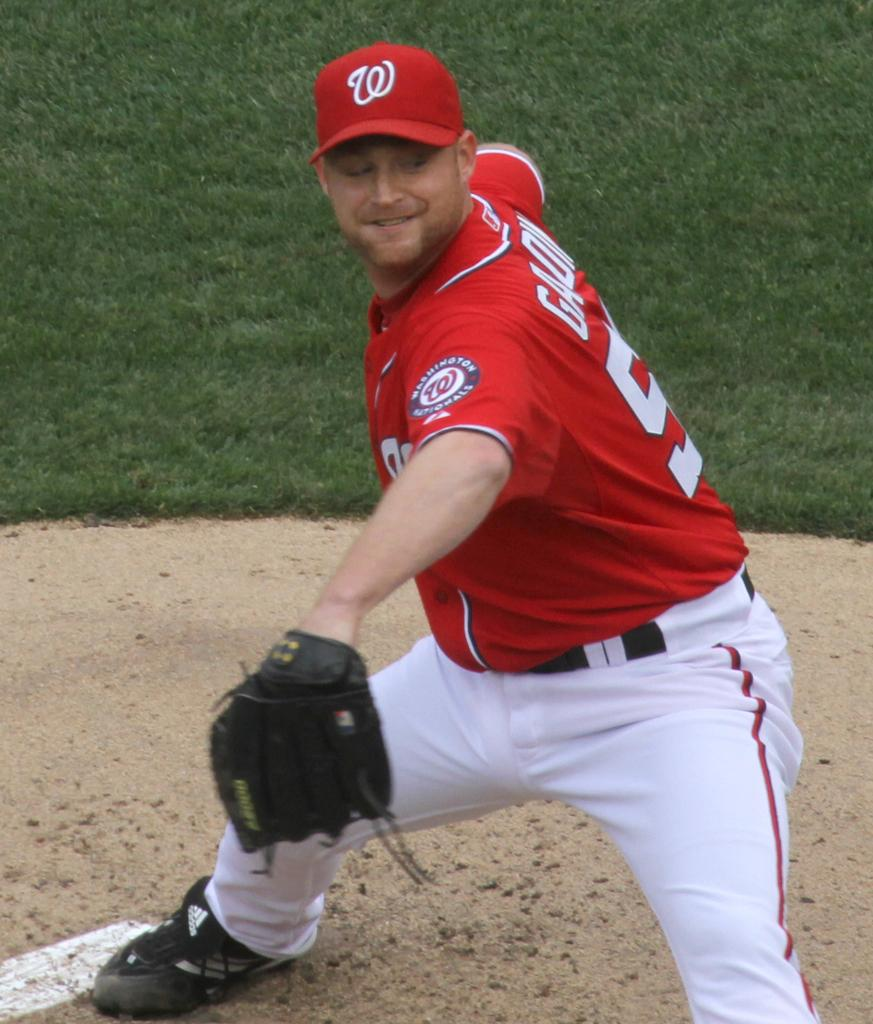<image>
Give a short and clear explanation of the subsequent image. a player with a W on their hat during a game 